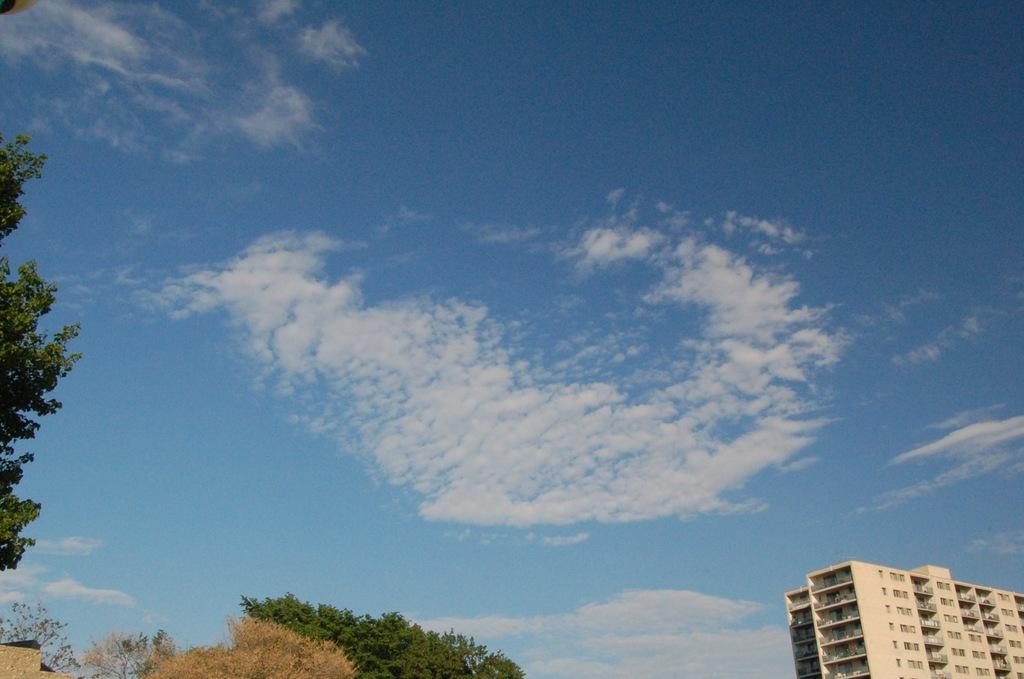What type of vegetation is at the bottom of the image? There are trees at the bottom of the image. What type of structure is also at the bottom of the image? There is a building at the bottom of the image. What can be seen on the left side of the image? There are trees on the left side of the image. What is visible in the background of the image? The sky is visible in the background of the image. What else can be seen in the background of the image? Clouds are present in the background of the image. What type of company is depicted in the image? There is no company depicted in the image; it features trees, a building, and clouds. What spot on the image is of particular interest? The question assumes there is a spot of particular interest, but the facts provided do not indicate any specific area of interest in the image. 